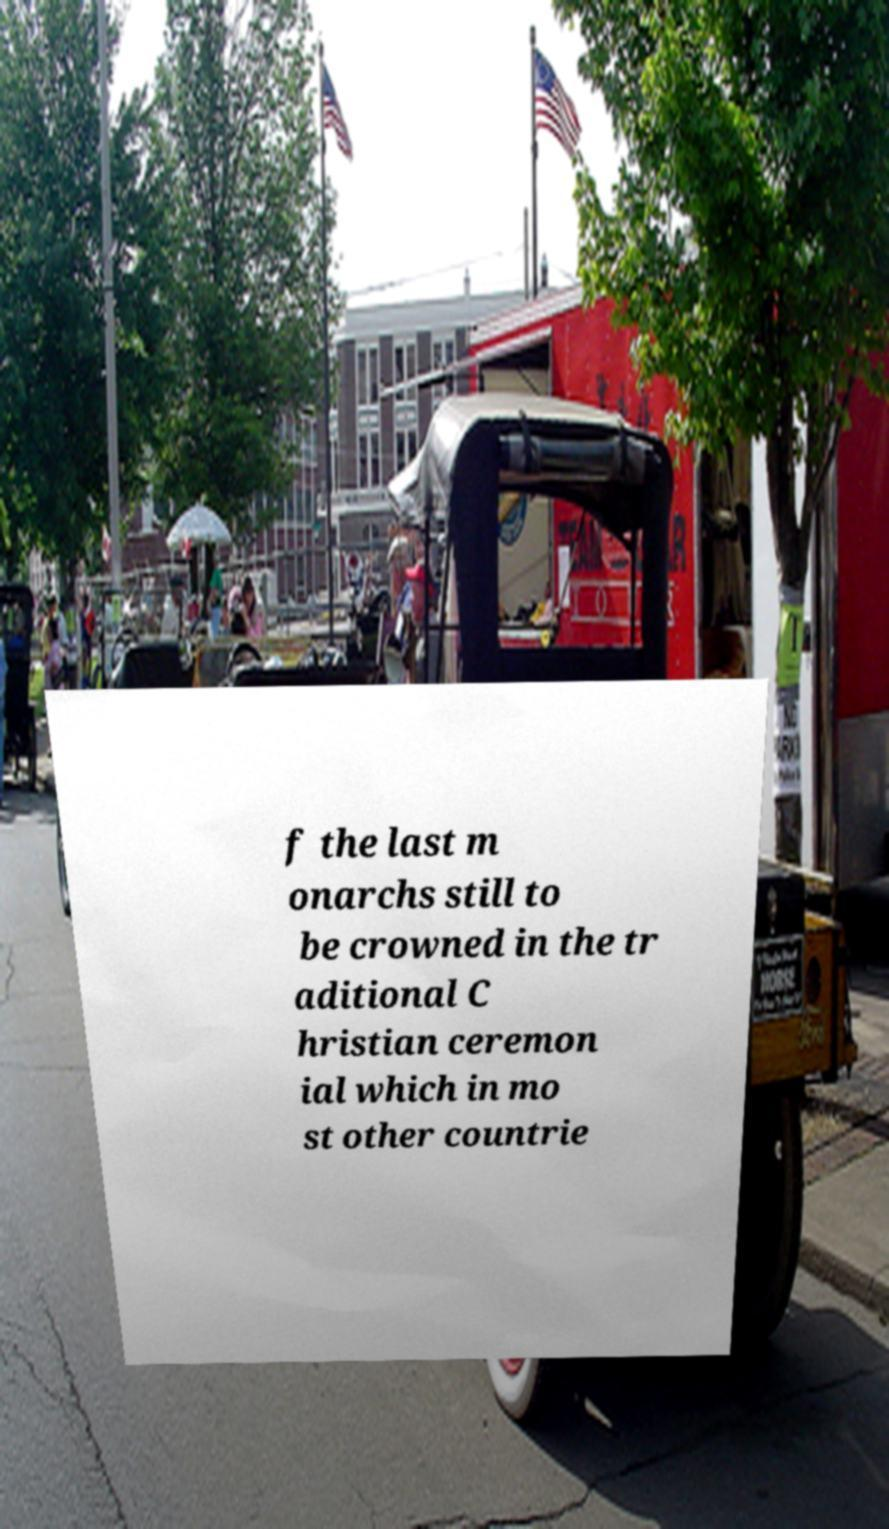There's text embedded in this image that I need extracted. Can you transcribe it verbatim? f the last m onarchs still to be crowned in the tr aditional C hristian ceremon ial which in mo st other countrie 